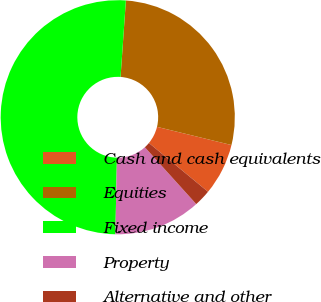<chart> <loc_0><loc_0><loc_500><loc_500><pie_chart><fcel>Cash and cash equivalents<fcel>Equities<fcel>Fixed income<fcel>Property<fcel>Alternative and other<nl><fcel>7.17%<fcel>27.71%<fcel>50.79%<fcel>12.02%<fcel>2.32%<nl></chart> 